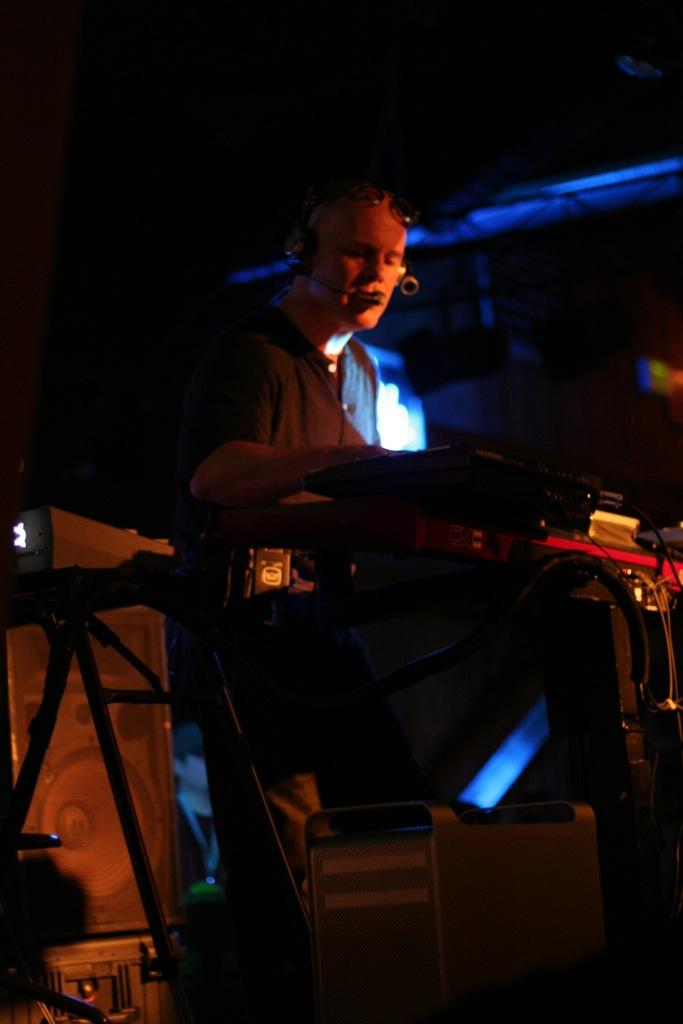What is the main subject of the image? The main subject of the image is a man standing in the middle of the image. What is the man wearing in the image? The man is wearing a headphone in the image. What can be seen on the right side of the image? There are objects on the right side of the image. How would you describe the background of the image? The background of the image is dark. What type of drink is the man holding in the image? The man is not holding any drink in the image. What sense is the man using to listen to music in the image? The man is using his sense of hearing to listen to music through the headphone, but we do not know if he is listening to music or any other audio. --- Facts: 1. There is a car in the image. 2. The car is parked on the street. 3. There are trees in the background of the image. 4. The sky is visible in the image. Absurd Topics: dance, book, bird Conversation: What is the main subject of the image? The main subject of the image is a car. Where is the car located in the image? The car is parked on the street in the image. What can be seen in the background of the image? There are trees in the background of the image. What is visible at the top of the image? The sky is visible in the image. Reasoning: Let's think step by step in order to produce the conversation. We start by identifying the main subject of the image, which is the car. Then, we describe the location of the car, which is parked on the street. Next, we mention the objects in the background, which are trees. Finally, we describe the sky's visibility at the top of the image. Absurd Question/Answer: What type of dance is the car performing in the image? Cars do not perform dances, so this question is not applicable to the image. What book is the car reading in the image? Cars do not read books, so this question is not applicable to the image. 